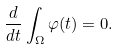Convert formula to latex. <formula><loc_0><loc_0><loc_500><loc_500>\frac { d } { d t } \int _ { \Omega } \varphi ( t ) = 0 .</formula> 